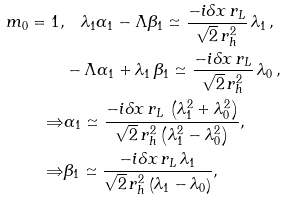Convert formula to latex. <formula><loc_0><loc_0><loc_500><loc_500>m _ { 0 } = 1 , & \quad \lambda _ { 1 } \alpha _ { 1 } - \Lambda \beta _ { 1 } \simeq \frac { - i \delta x \, r _ { L } } { \sqrt { 2 } \, r _ { h } ^ { 2 } } \, \lambda _ { 1 } \, , \\ & - \Lambda \alpha _ { 1 } + \lambda _ { 1 } \, \beta _ { 1 } \simeq \frac { - i \delta x \, r _ { L } } { \sqrt { 2 } \, r _ { h } ^ { 2 } } \, \lambda _ { 0 } \, , \\ \Rightarrow & \alpha _ { 1 } \simeq \frac { - i \delta x \, r _ { L } \, \left ( \lambda _ { 1 } ^ { 2 } + \lambda _ { 0 } ^ { 2 } \right ) } { \sqrt { 2 } \, r _ { h } ^ { 2 } \left ( \lambda _ { 1 } ^ { 2 } - \lambda _ { 0 } ^ { 2 } \right ) } , \\ \Rightarrow & \beta _ { 1 } \simeq \frac { - i \delta x \, r _ { L } \, \lambda _ { 1 } } { \sqrt { 2 } \, r _ { h } ^ { 2 } \left ( \lambda _ { 1 } - \lambda _ { 0 } \right ) } ,</formula> 